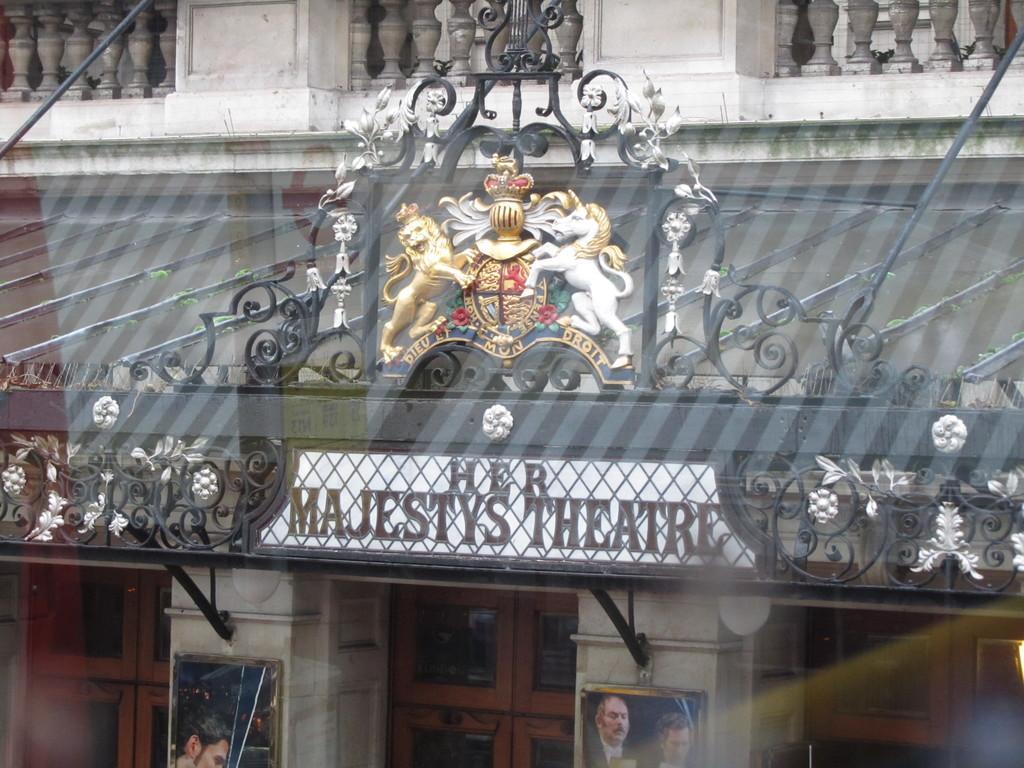What type of structure is visible in the image? There is a building in the image. What can be seen on the board in the image? There is a board with text in the image. What decorative elements are present on the pillars in the image? There are photos on the pillars in the image. Can you describe the architectural feature at the top of the building? There appears to be a balcony at the top of the building in the image. What is the historical significance of the surprise event that took place on the balcony in the image? There is no mention of a surprise event or historical significance in the image; it only shows a building with a balcony at the top. 